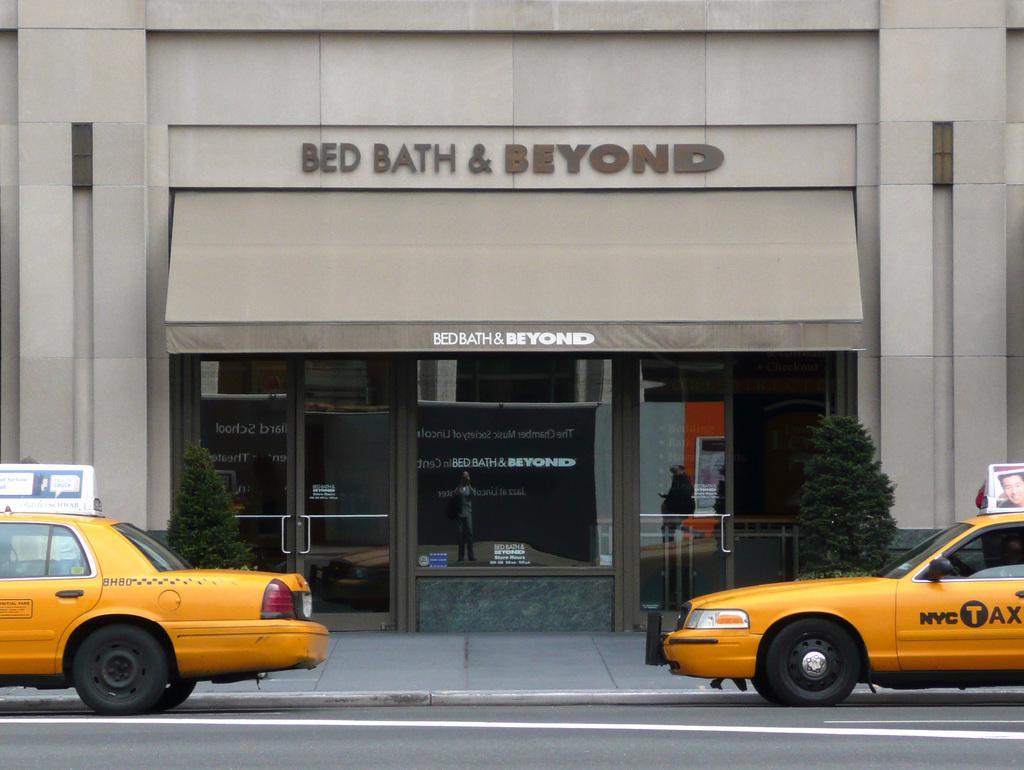In one or two sentences, can you explain what this image depicts? In the center of the image there is a building. At the bottom we can see cars on the road and there are bushes. 